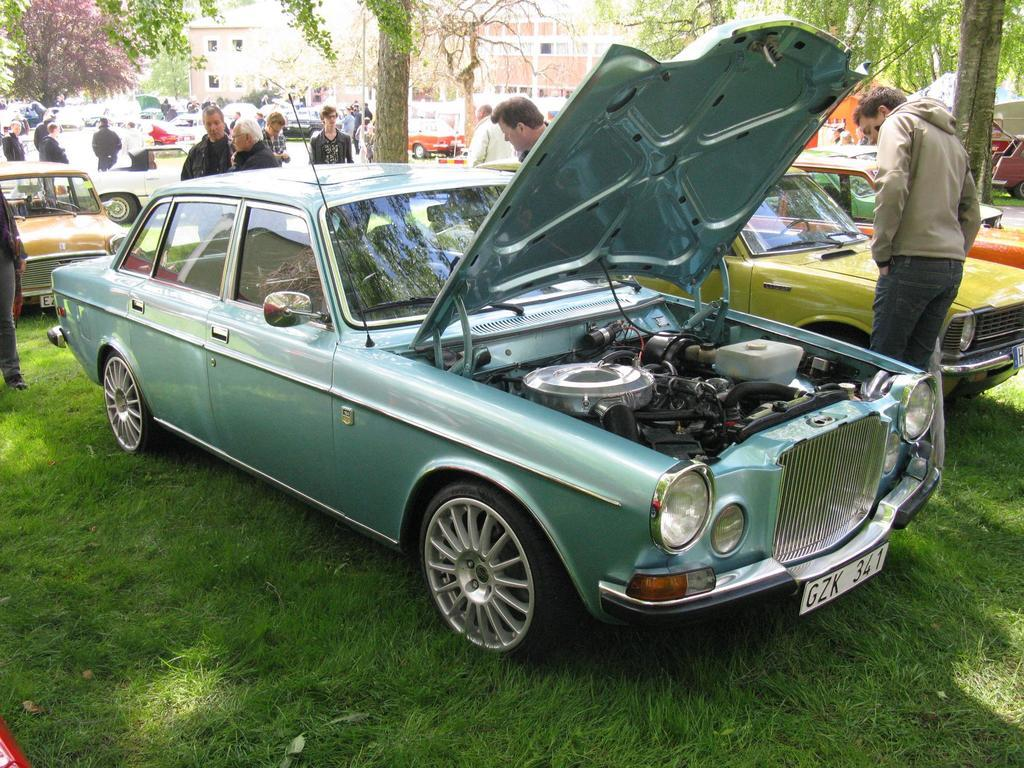What type of vehicles can be seen in the image? There are cars in the image. Who or what else is present in the image? There are people in the image. What type of natural environment is visible in the image? There is grass visible in the image. What can be seen in the distance in the image? There are trees and buildings in the background of the image. What type of print can be seen on the donkey in the image? There is no donkey present in the image, so it is not possible to determine if there is any print on it. 